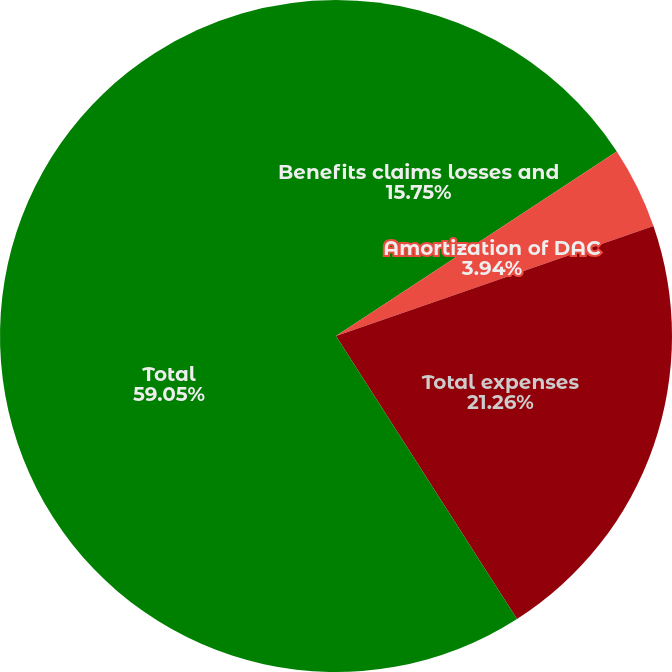Convert chart to OTSL. <chart><loc_0><loc_0><loc_500><loc_500><pie_chart><fcel>Benefits claims losses and<fcel>Amortization of DAC<fcel>Total expenses<fcel>Total<nl><fcel>15.75%<fcel>3.94%<fcel>21.26%<fcel>59.06%<nl></chart> 